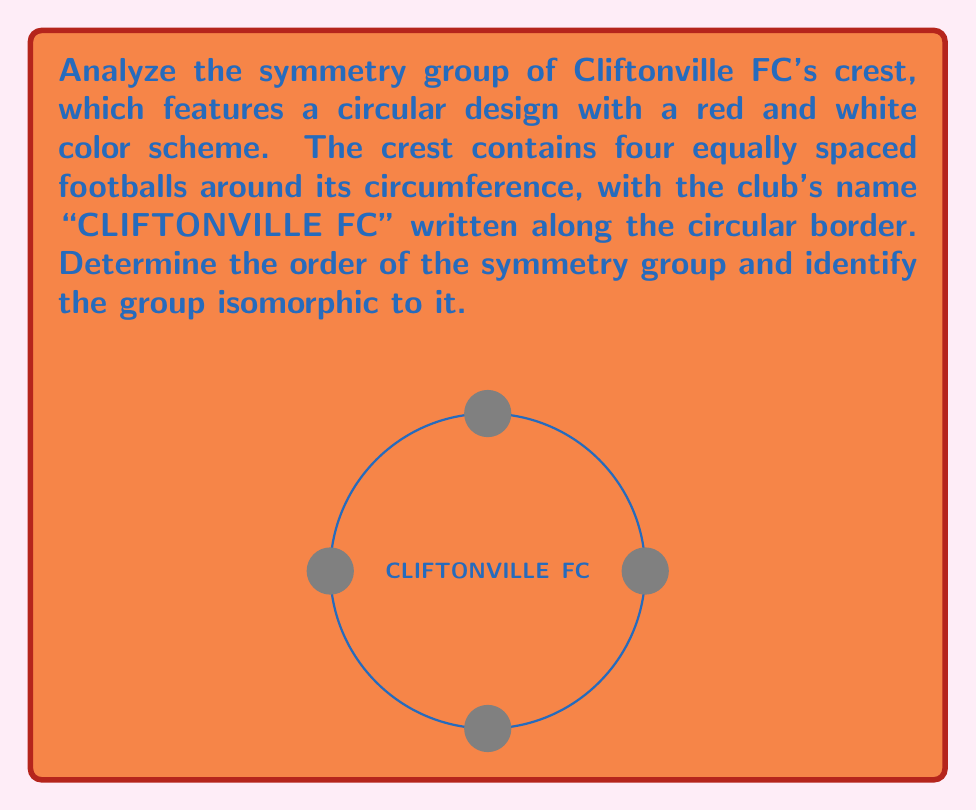Show me your answer to this math problem. To analyze the symmetry group of Cliftonville FC's crest, we need to consider both rotational and reflectional symmetries:

1) Rotational symmetries:
   - The crest has 4-fold rotational symmetry due to the four equally spaced footballs.
   - It can be rotated by 90°, 180°, 270°, and 360° (which is equivalent to 0°) to map onto itself.
   - This gives us 4 rotational symmetries, including the identity rotation.

2) Reflectional symmetries:
   - There are 4 lines of reflection: vertical, horizontal, and two diagonal lines passing through the center.
   - Each of these reflections maps the crest onto itself.

3) Total number of symmetries:
   - The total number of symmetries is the sum of rotational and reflectional symmetries.
   - Thus, the order of the symmetry group is 4 + 4 = 8.

4) Group structure:
   - The symmetry group contains rotations of order 4 and reflections.
   - This structure is identical to the dihedral group of order 8, denoted as $D_4$ or $D_8$ (depending on notation convention).

5) Group properties:
   - $D_4$ is non-abelian, as rotations and reflections do not generally commute.
   - It has 8 elements: $\{e, r, r^2, r^3, s, sr, sr^2, sr^3\}$, where $r$ is a 90° rotation and $s$ is a reflection.

Therefore, the symmetry group of Cliftonville FC's crest is isomorphic to the dihedral group $D_4$ (or $D_8$), which has order 8.
Answer: $D_4$ (or $D_8$), order 8 